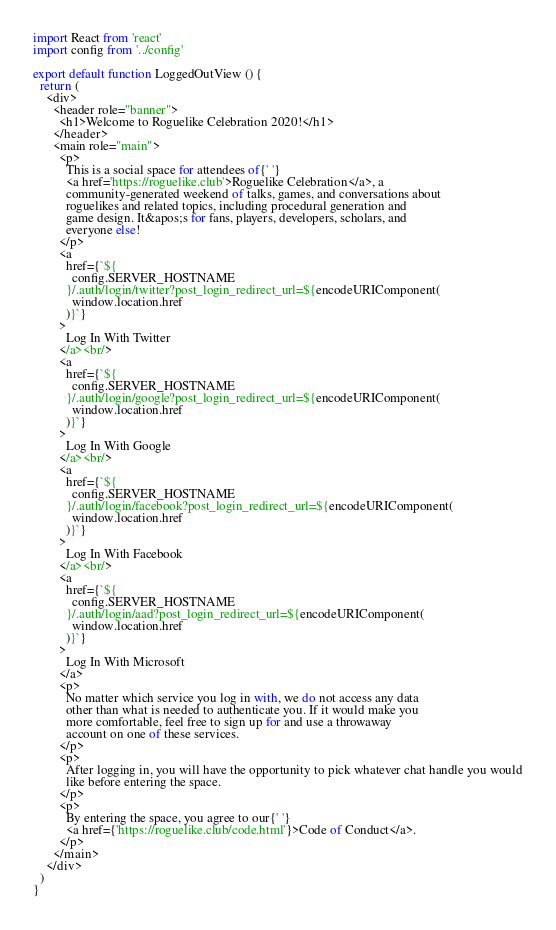Convert code to text. <code><loc_0><loc_0><loc_500><loc_500><_TypeScript_>import React from 'react'
import config from '../config'

export default function LoggedOutView () {
  return (
    <div>
      <header role="banner">
        <h1>Welcome to Roguelike Celebration 2020!</h1>
      </header>
      <main role="main">
        <p>
          This is a social space for attendees of{' '}
          <a href='https://roguelike.club'>Roguelike Celebration</a>, a
          community-generated weekend of talks, games, and conversations about
          roguelikes and related topics, including procedural generation and
          game design. It&apos;s for fans, players, developers, scholars, and
          everyone else!
        </p>
        <a
          href={`${
            config.SERVER_HOSTNAME
          }/.auth/login/twitter?post_login_redirect_url=${encodeURIComponent(
            window.location.href
          )}`}
        >
          Log In With Twitter
        </a><br/>
        <a
          href={`${
            config.SERVER_HOSTNAME
          }/.auth/login/google?post_login_redirect_url=${encodeURIComponent(
            window.location.href
          )}`}
        >
          Log In With Google
        </a><br/>
        <a
          href={`${
            config.SERVER_HOSTNAME
          }/.auth/login/facebook?post_login_redirect_url=${encodeURIComponent(
            window.location.href
          )}`}
        >
          Log In With Facebook
        </a><br/>
        <a
          href={`${
            config.SERVER_HOSTNAME
          }/.auth/login/aad?post_login_redirect_url=${encodeURIComponent(
            window.location.href
          )}`}
        >
          Log In With Microsoft
        </a>
        <p>
          No matter which service you log in with, we do not access any data
          other than what is needed to authenticate you. If it would make you
          more comfortable, feel free to sign up for and use a throwaway
          account on one of these services.
        </p>
        <p>
          After logging in, you will have the opportunity to pick whatever chat handle you would
          like before entering the space.
        </p>
        <p>
          By entering the space, you agree to our{' '}
          <a href={'https://roguelike.club/code.html'}>Code of Conduct</a>.
        </p>
      </main>
    </div>
  )
}
</code> 